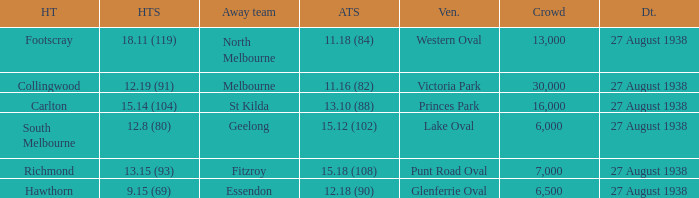How many people witnessed their home team score 13.15 (93)? 7000.0. 